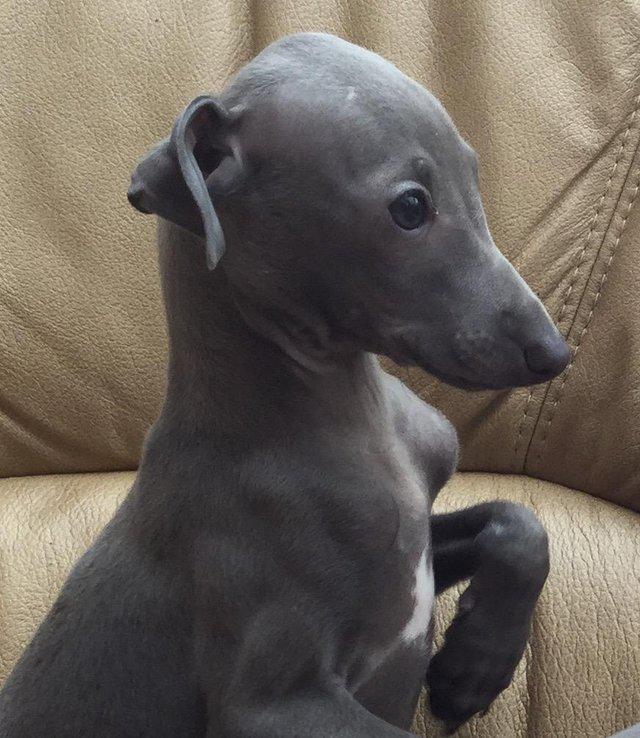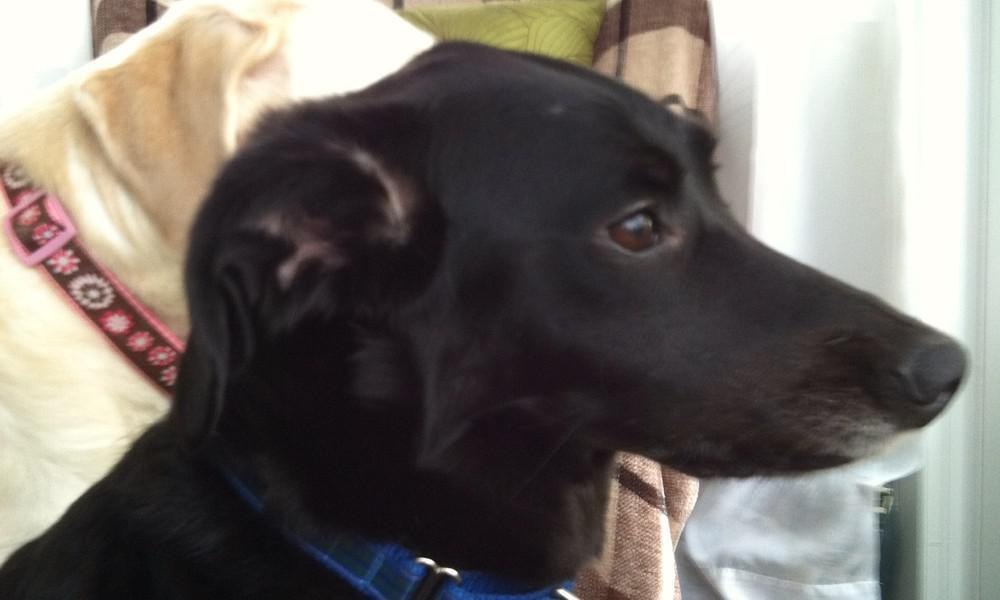The first image is the image on the left, the second image is the image on the right. For the images displayed, is the sentence "Two dogs are looking straight ahead." factually correct? Answer yes or no. No. 